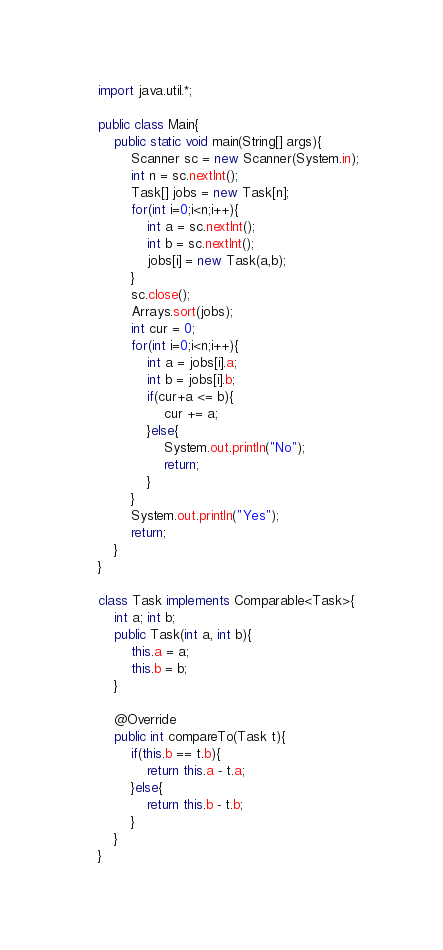<code> <loc_0><loc_0><loc_500><loc_500><_Java_>import java.util.*;

public class Main{
    public static void main(String[] args){
        Scanner sc = new Scanner(System.in);
        int n = sc.nextInt();
        Task[] jobs = new Task[n];
        for(int i=0;i<n;i++){
            int a = sc.nextInt();
            int b = sc.nextInt();
            jobs[i] = new Task(a,b);
        }
        sc.close();
        Arrays.sort(jobs);
        int cur = 0;
        for(int i=0;i<n;i++){
            int a = jobs[i].a;
            int b = jobs[i].b;
            if(cur+a <= b){
                cur += a;
            }else{
                System.out.println("No");
                return;
            }            
        }
        System.out.println("Yes");
        return;
    }
}

class Task implements Comparable<Task>{
    int a; int b;
    public Task(int a, int b){
        this.a = a;
        this.b = b;
    }

    @Override
    public int compareTo(Task t){
        if(this.b == t.b){
            return this.a - t.a;
        }else{
            return this.b - t.b;
        }
    }
}</code> 